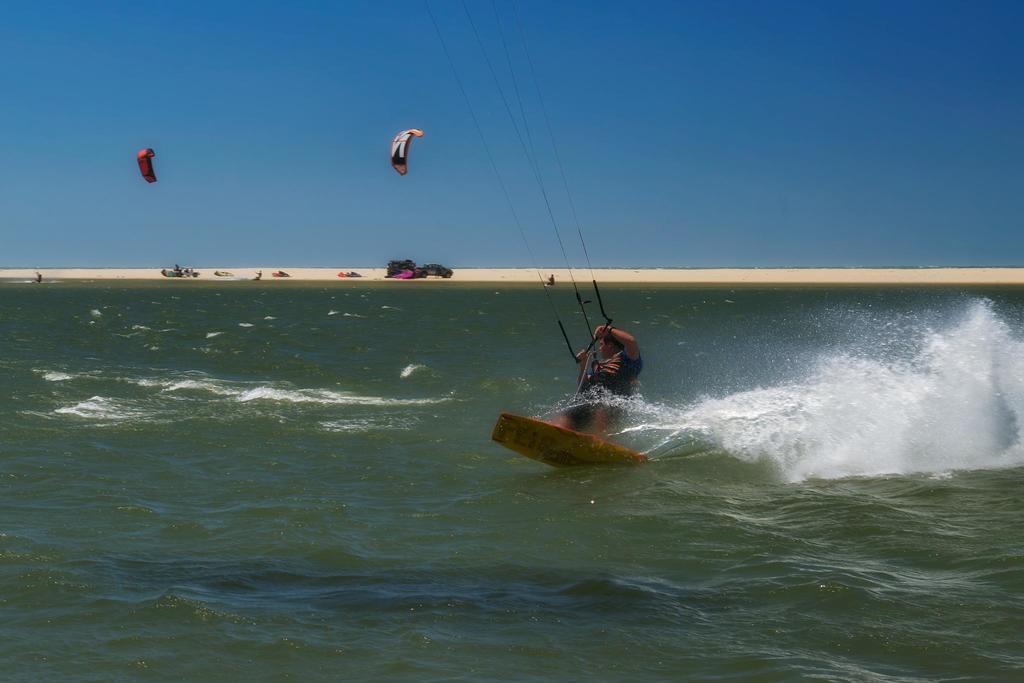How would you summarize this image in a sentence or two? In this picture I can see there is an ocean and there is a man holding a rope and in the backdrop there is sand and the sky is clear. 